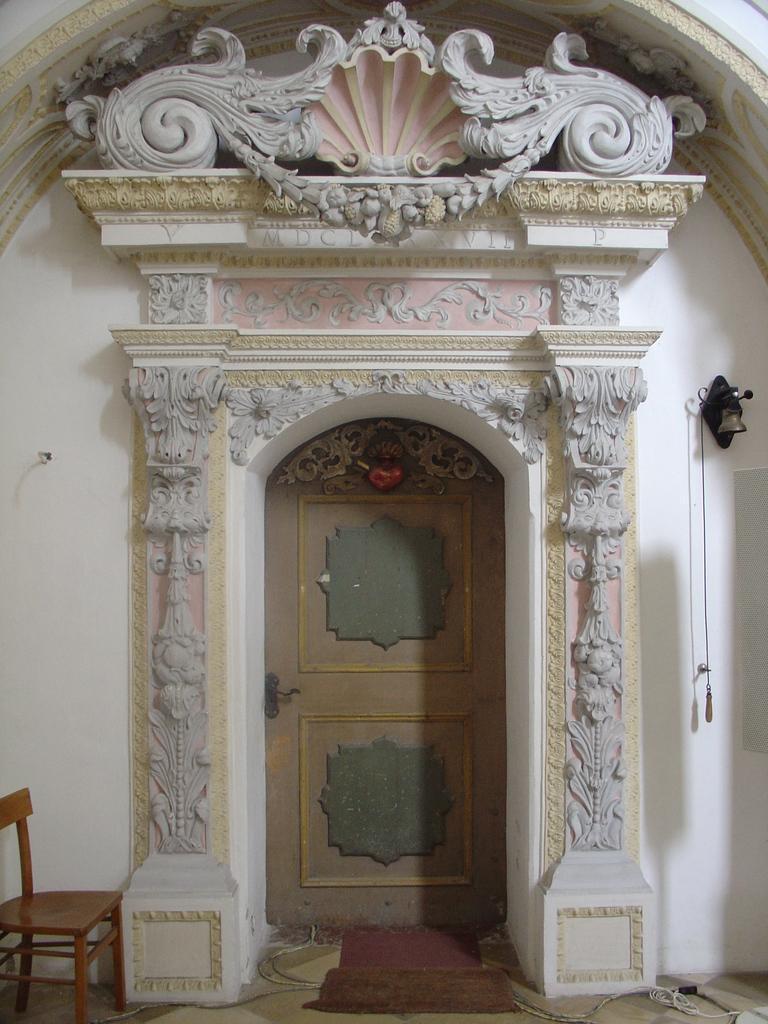Please provide a concise description of this image. In this picture we can see a door in the middle, on the right side we can see a bell and a wall, at the left bottom there is a chair. 